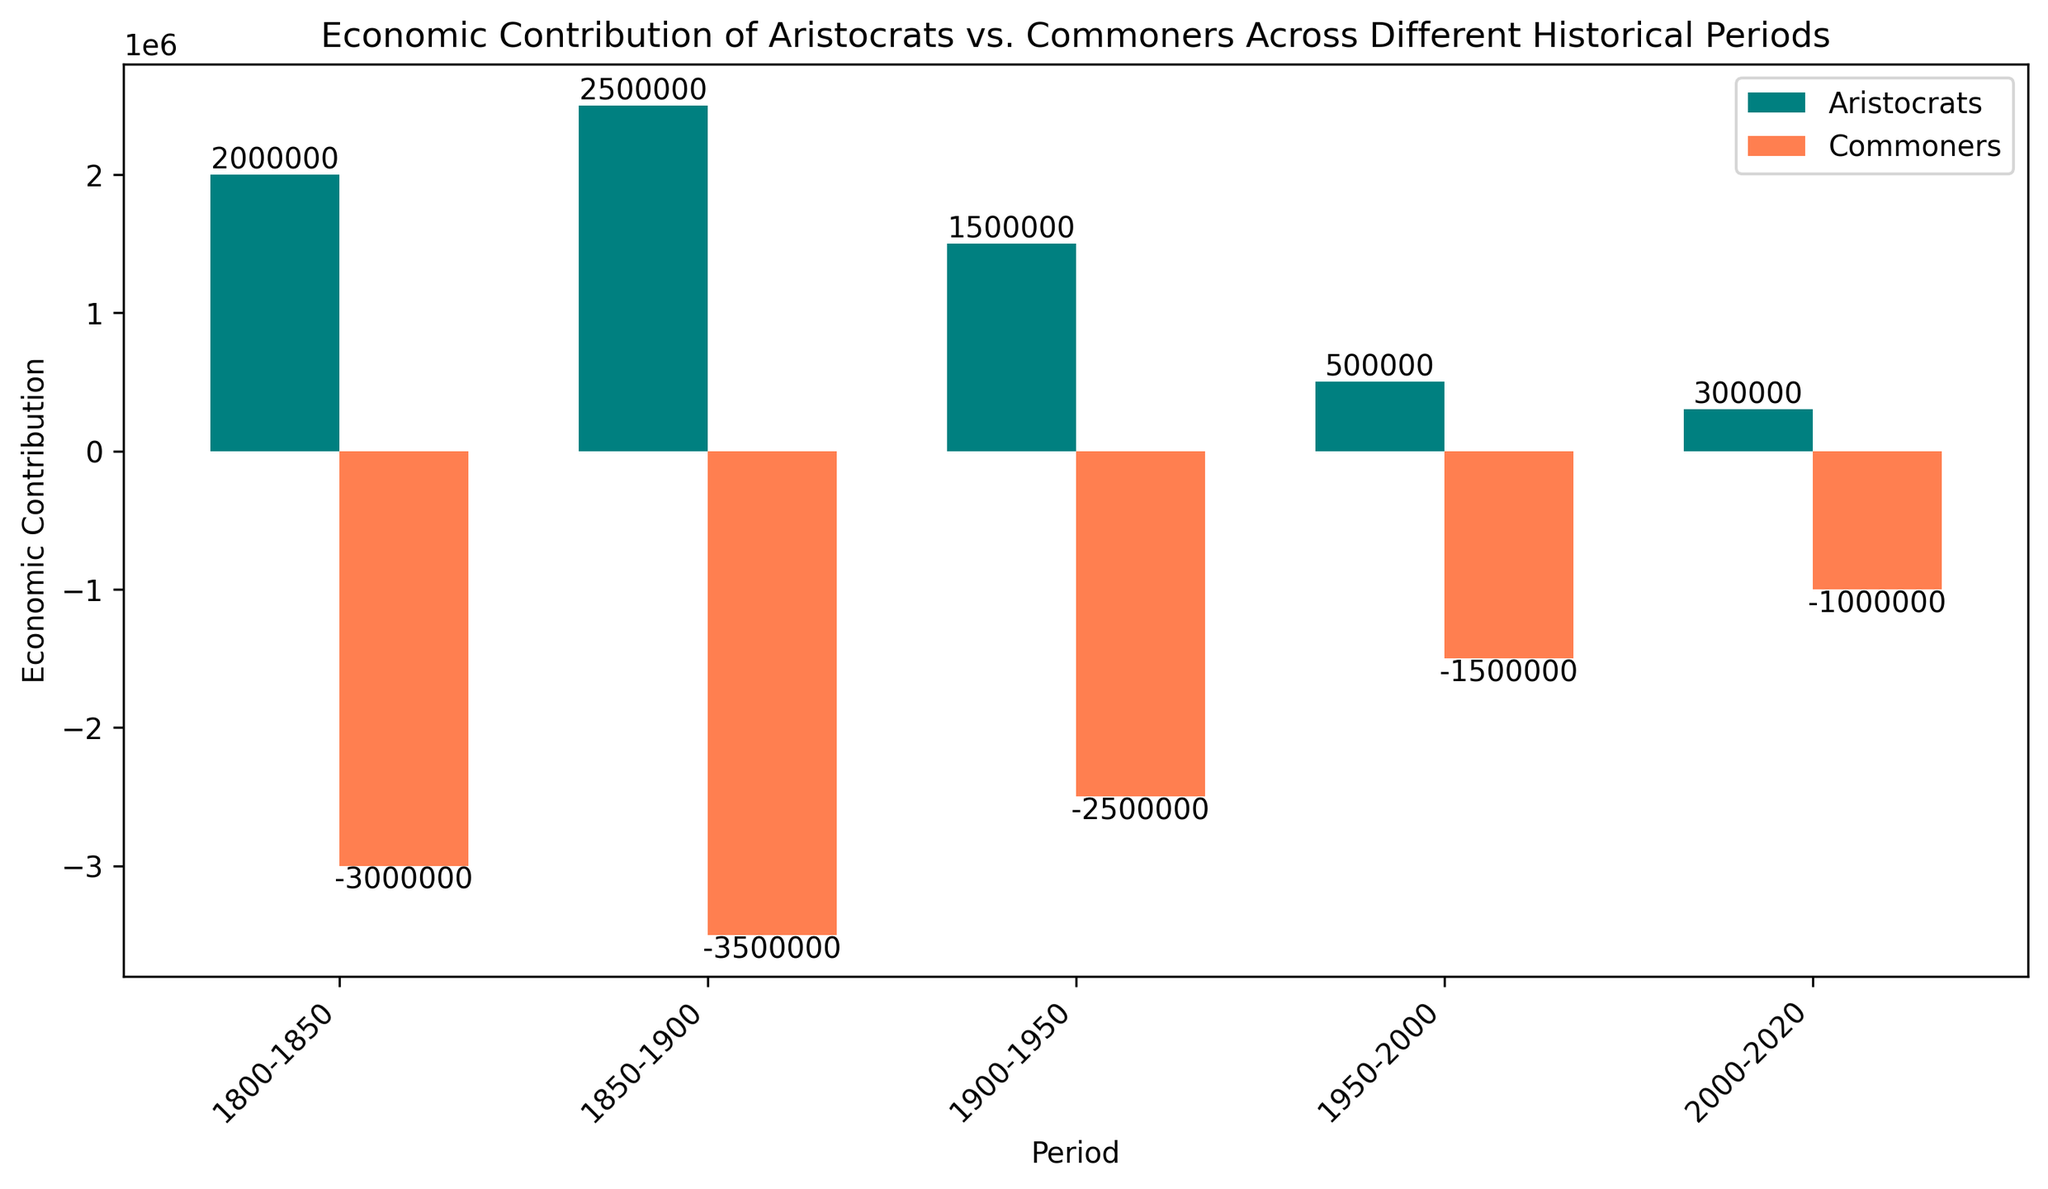what is the economic contribution of aristocrats in the period 1850-1900? Look at the bar corresponding to the aristocrats in the period 1850-1900. The height of the teal bar shows the value.
Answer: 2500000 Who contributed more economically in the period 1900-1950, aristocrats or commoners? Compare the heights of the teal (aristocrats) and coral (commoners) bars for the period 1900-1950. The aristocrats' bar is higher than the commoners' bar.
Answer: Aristocrats Which historical period showed the largest negative economic contribution from commoners? Identify the period with the highest (most negative) coral bar. The period 1850-1900 has the highest negative contribution.
Answer: 1850-1900 By how much did the economic contribution of aristocrats decrease from the period 1850-1900 to 1950-2000? Look at the heights of the teal bars for both periods. Subtract the contribution in 1950-2000 (500000) from 1850-1900 (2500000).
Answer: 2000000 What is the total economic contribution of aristocrats across all periods? Sum the values of the teal bars: 2000000 + 2500000 + 1500000 + 500000 + 300000.
Answer: 6800000 How has the economic contribution of commoners changed over the periods from 1800-2020? Look at the commoners' (coral) bars across all periods. It consistently shows negative economic contributions, but the magnitude of the negativity decreases over time.
Answer: Decreased negativity What is the difference in economic contribution between aristocrats and commoners in the period 2000-2020? Subtract the commoners' (coral) value from the aristocrats' (teal) value in that period: 300000 - (-1000000).
Answer: 1300000 Which period shows the smallest economic contribution from aristocrats? Identify the period with the shortest teal bar. The bar for the period 2000-2020 is the shortest in height.
Answer: 2000-2020 What is the average economic contribution of commoners over all periods? Sum the economic contributions of commoners over all periods and divide by the number of periods: (-3000000 + -3500000 + -2500000 + 1500000 + -1000000) / 5.
Answer: -2100000 What is the total economic contribution difference between aristocrats and commoners over all periods? Calculate the total for aristocrats (6800000) and commoners (-11500000). The difference is 6800000 - (-11500000).
Answer: 18300000 